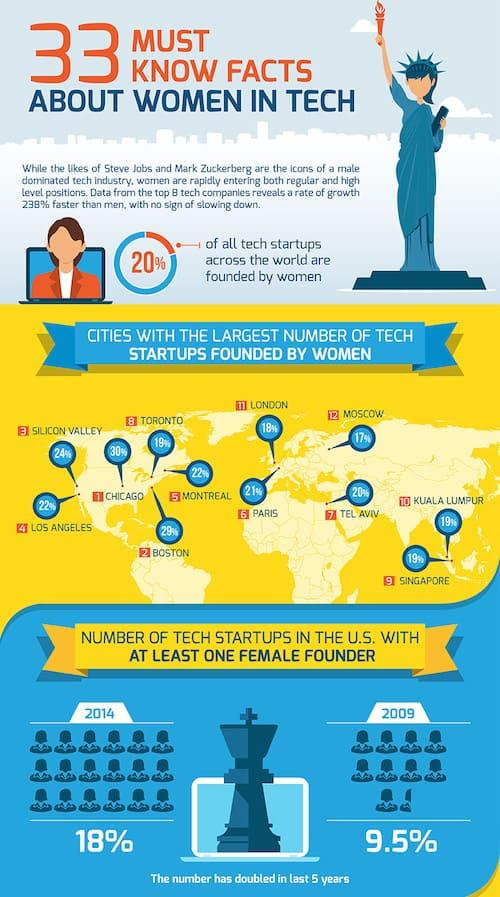List a handful of essential elements in this visual. In 2009, only 9.5% of tech startups in the U.S. had at least one female founder. A recent survey revealed that only 18% of tech startups in London were founded by women. There are 8 tech startups founded by women in Toronto. In 2014, it was found that 18% of tech startups in the U.S. had at least one female founder. In Boston, 29% of tech startups were founded by women. 